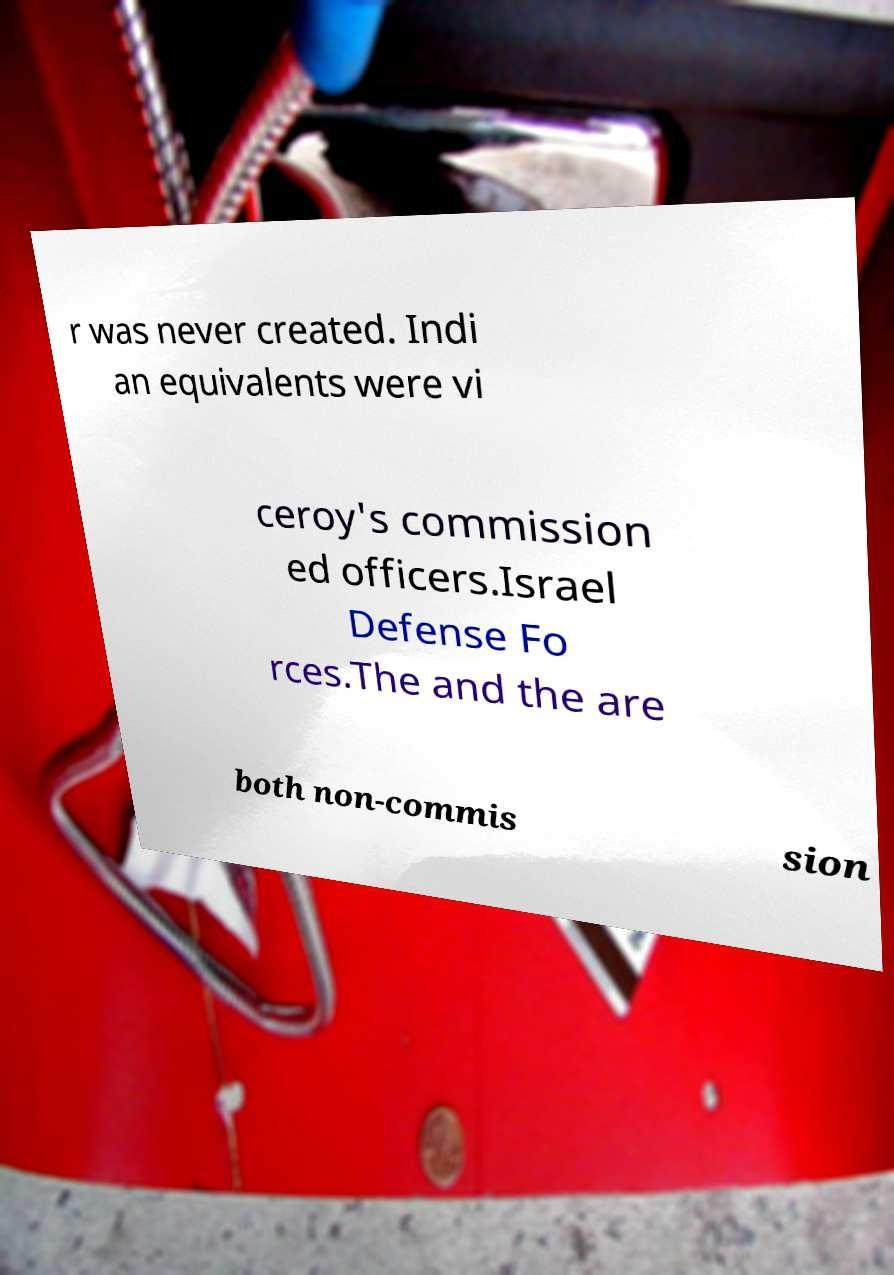What messages or text are displayed in this image? I need them in a readable, typed format. r was never created. Indi an equivalents were vi ceroy's commission ed officers.Israel Defense Fo rces.The and the are both non-commis sion 